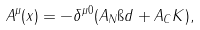<formula> <loc_0><loc_0><loc_500><loc_500>A ^ { \mu } ( x ) = - \delta ^ { \mu 0 } ( A _ { N } \i d + A _ { C } K ) ,</formula> 